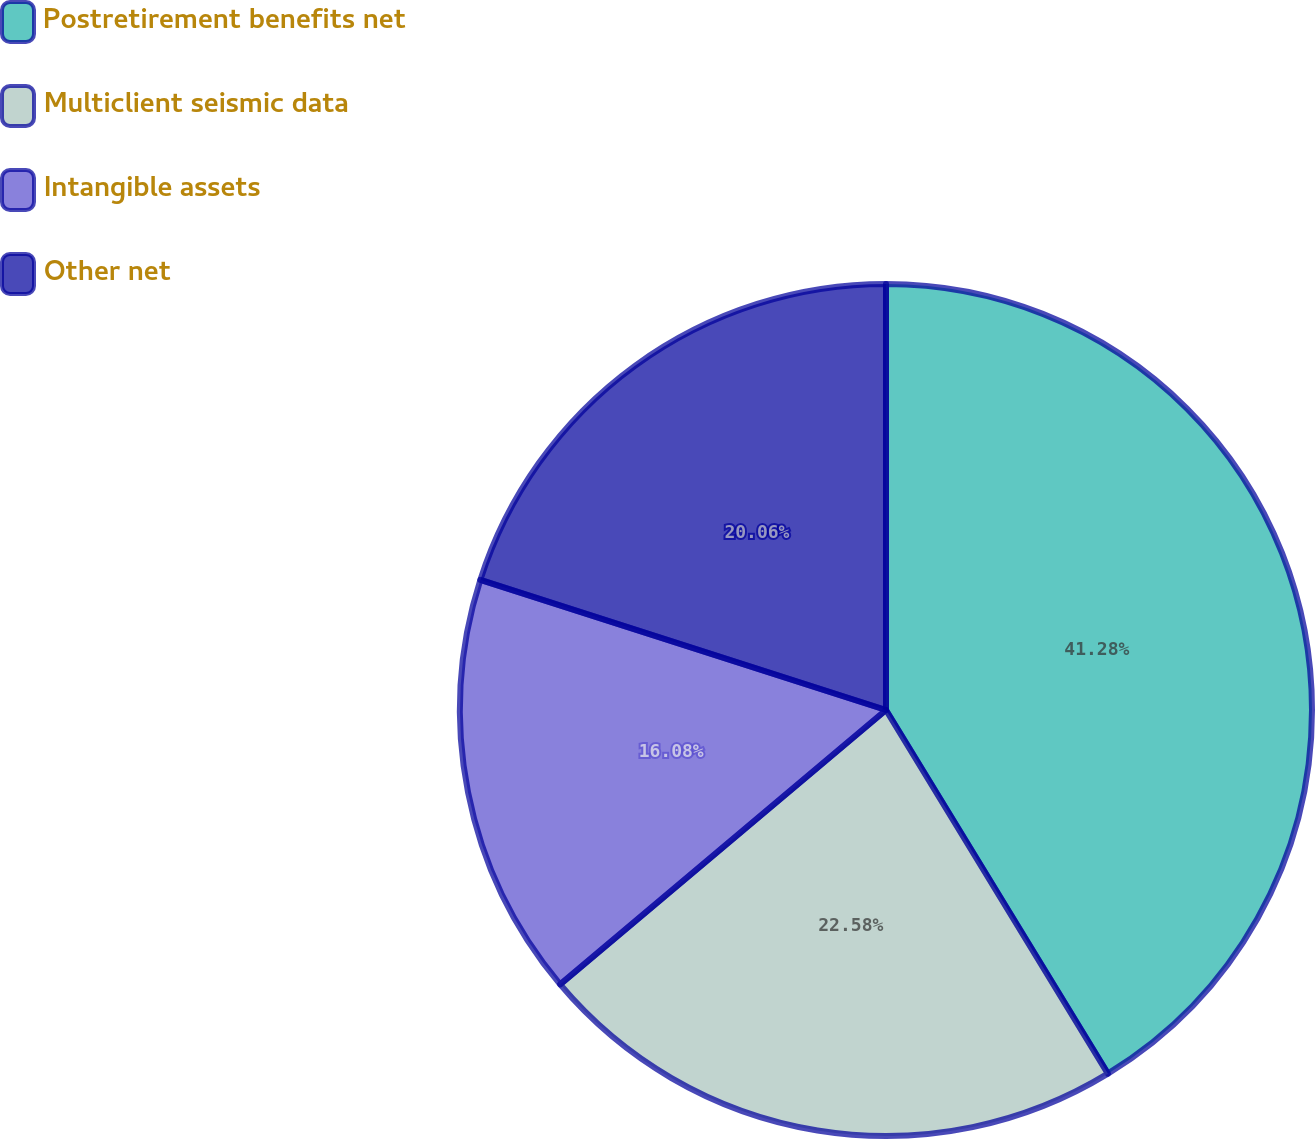Convert chart to OTSL. <chart><loc_0><loc_0><loc_500><loc_500><pie_chart><fcel>Postretirement benefits net<fcel>Multiclient seismic data<fcel>Intangible assets<fcel>Other net<nl><fcel>41.28%<fcel>22.58%<fcel>16.08%<fcel>20.06%<nl></chart> 